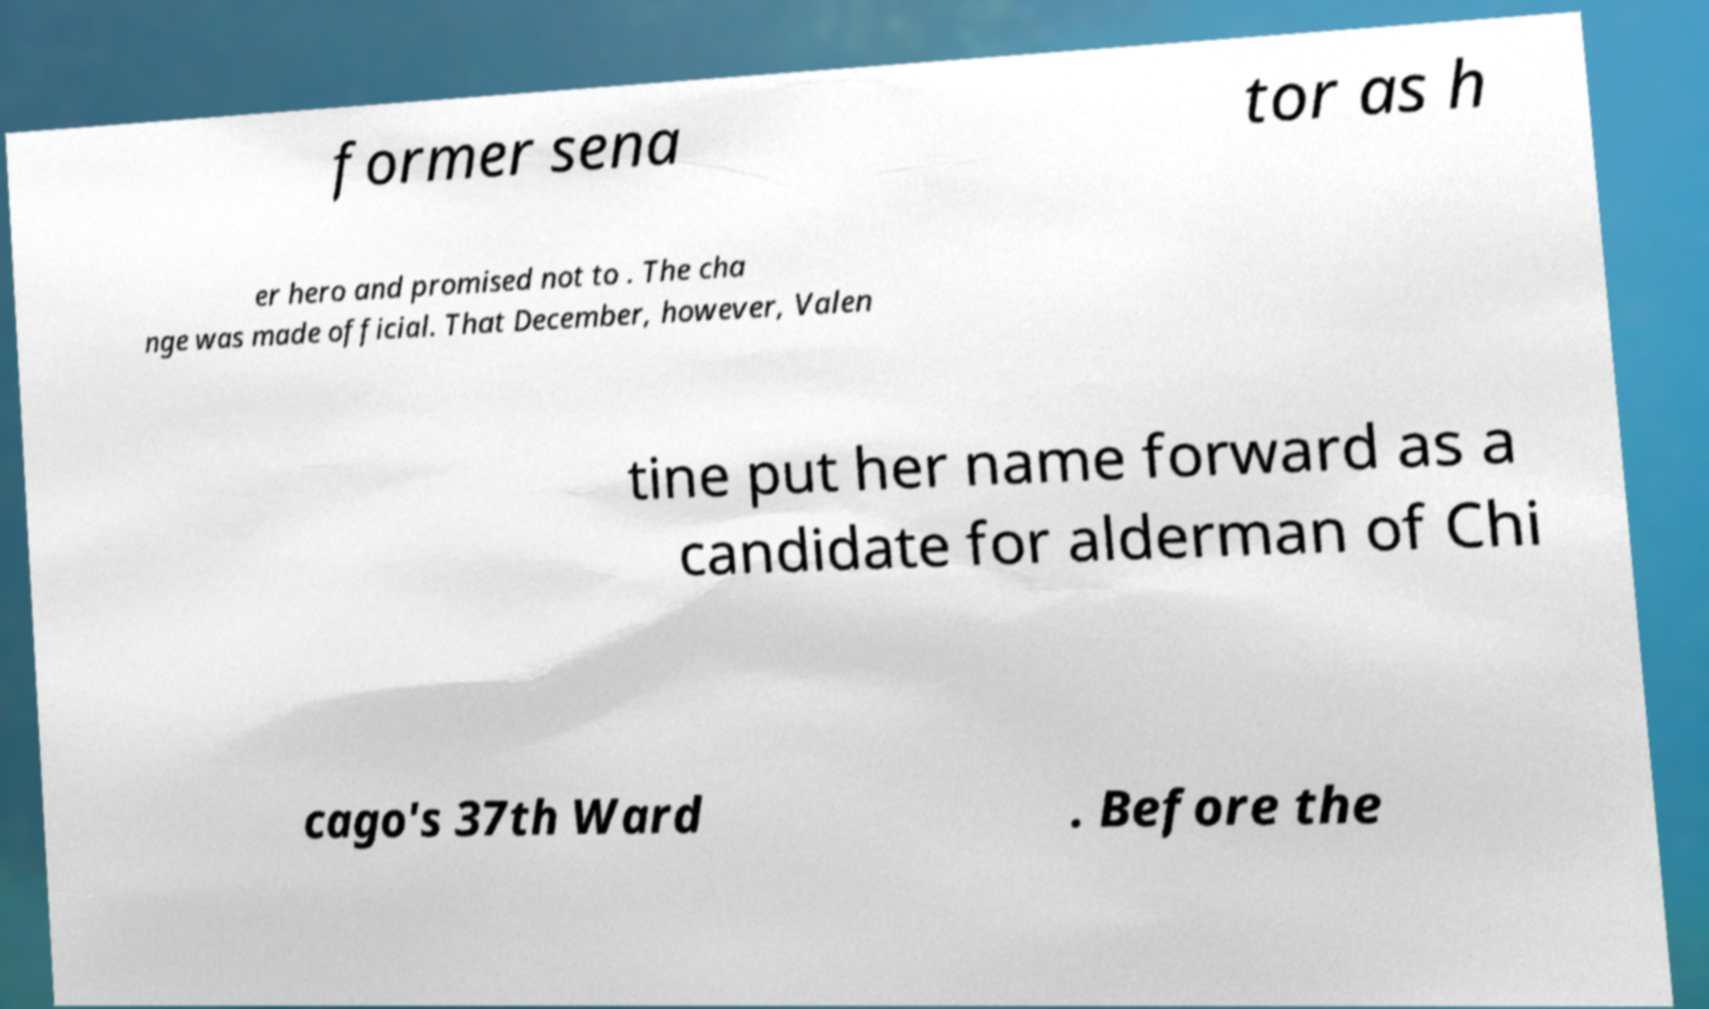For documentation purposes, I need the text within this image transcribed. Could you provide that? former sena tor as h er hero and promised not to . The cha nge was made official. That December, however, Valen tine put her name forward as a candidate for alderman of Chi cago's 37th Ward . Before the 